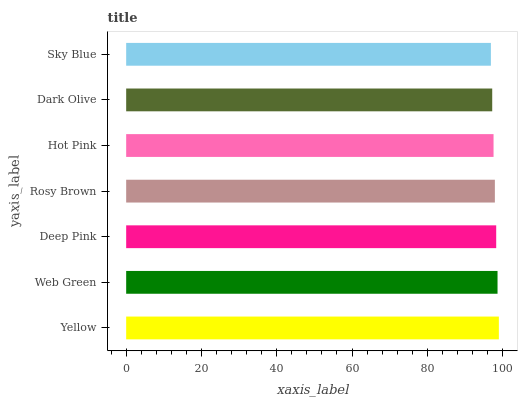Is Sky Blue the minimum?
Answer yes or no. Yes. Is Yellow the maximum?
Answer yes or no. Yes. Is Web Green the minimum?
Answer yes or no. No. Is Web Green the maximum?
Answer yes or no. No. Is Yellow greater than Web Green?
Answer yes or no. Yes. Is Web Green less than Yellow?
Answer yes or no. Yes. Is Web Green greater than Yellow?
Answer yes or no. No. Is Yellow less than Web Green?
Answer yes or no. No. Is Rosy Brown the high median?
Answer yes or no. Yes. Is Rosy Brown the low median?
Answer yes or no. Yes. Is Deep Pink the high median?
Answer yes or no. No. Is Sky Blue the low median?
Answer yes or no. No. 